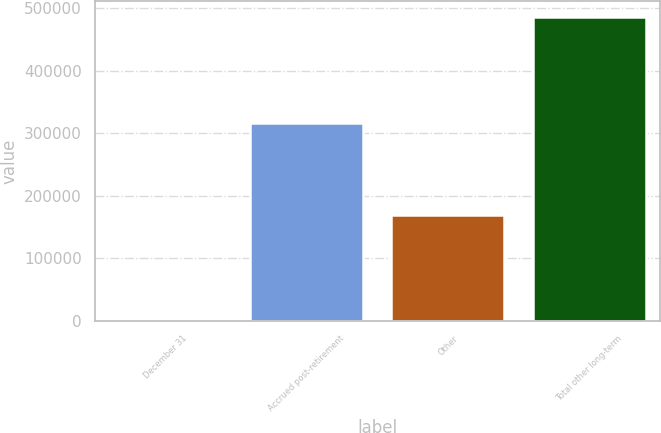Convert chart to OTSL. <chart><loc_0><loc_0><loc_500><loc_500><bar_chart><fcel>December 31<fcel>Accrued post-retirement<fcel>Other<fcel>Total other long-term<nl><fcel>2006<fcel>316455<fcel>170018<fcel>486473<nl></chart> 